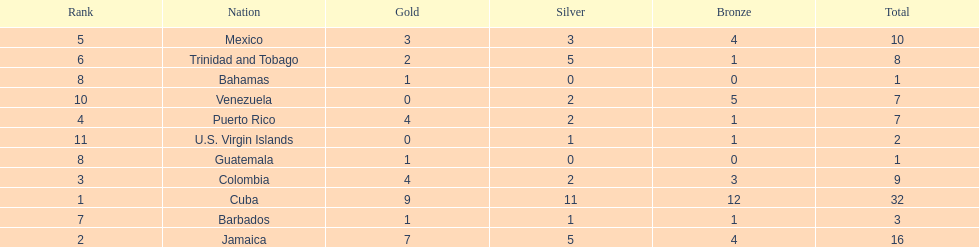What is the difference in medals between cuba and mexico? 22. 